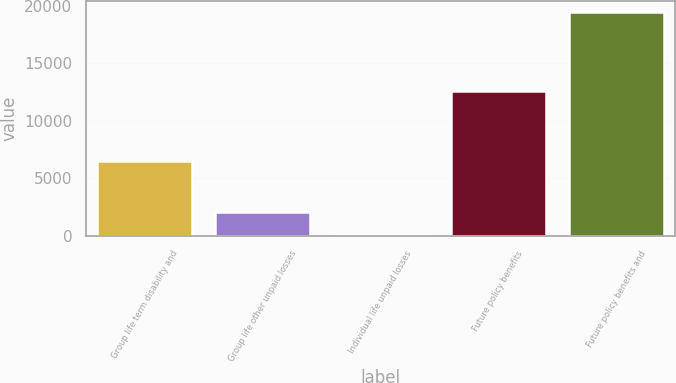Convert chart. <chart><loc_0><loc_0><loc_500><loc_500><bar_chart><fcel>Group life term disability and<fcel>Group life other unpaid losses<fcel>Individual life unpaid losses<fcel>Future policy benefits<fcel>Future policy benefits and<nl><fcel>6547<fcel>2067.2<fcel>134<fcel>12572<fcel>19466<nl></chart> 